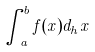<formula> <loc_0><loc_0><loc_500><loc_500>\int _ { a } ^ { b } f ( x ) d _ { h } x</formula> 